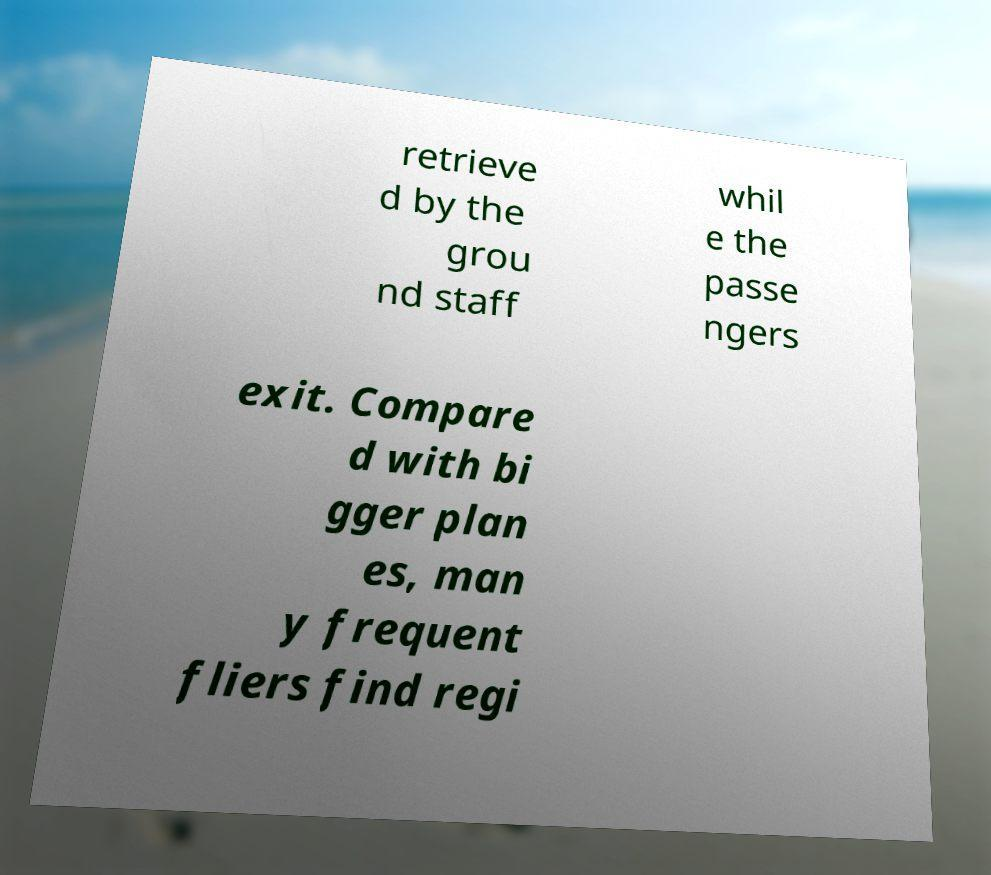For documentation purposes, I need the text within this image transcribed. Could you provide that? retrieve d by the grou nd staff whil e the passe ngers exit. Compare d with bi gger plan es, man y frequent fliers find regi 